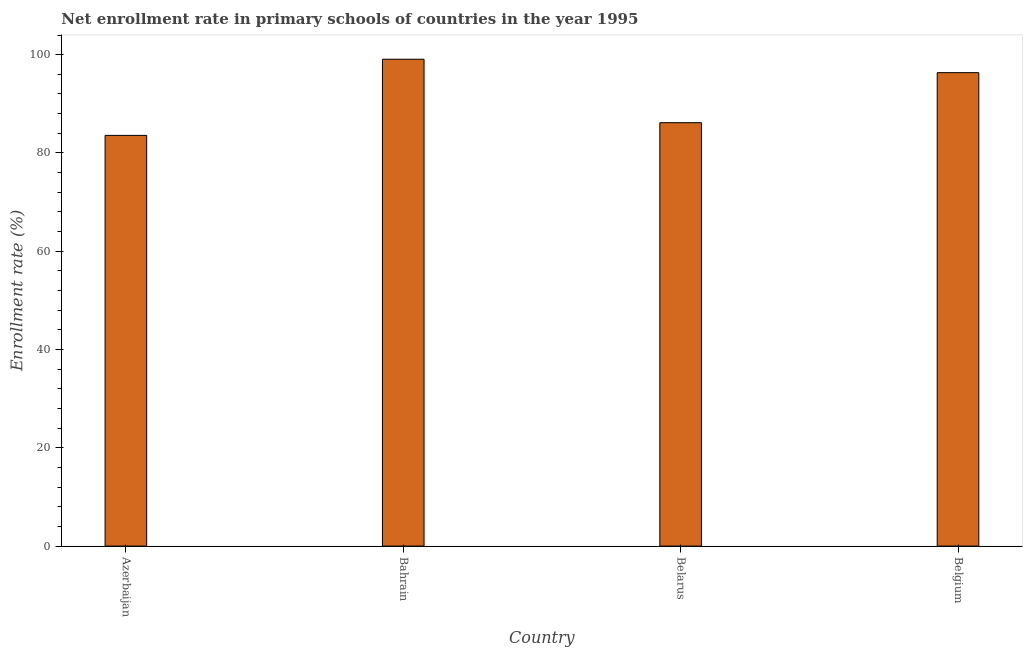What is the title of the graph?
Give a very brief answer. Net enrollment rate in primary schools of countries in the year 1995. What is the label or title of the X-axis?
Ensure brevity in your answer.  Country. What is the label or title of the Y-axis?
Offer a terse response. Enrollment rate (%). What is the net enrollment rate in primary schools in Belgium?
Offer a terse response. 96.34. Across all countries, what is the maximum net enrollment rate in primary schools?
Ensure brevity in your answer.  99.07. Across all countries, what is the minimum net enrollment rate in primary schools?
Ensure brevity in your answer.  83.57. In which country was the net enrollment rate in primary schools maximum?
Offer a terse response. Bahrain. In which country was the net enrollment rate in primary schools minimum?
Keep it short and to the point. Azerbaijan. What is the sum of the net enrollment rate in primary schools?
Offer a very short reply. 365.15. What is the difference between the net enrollment rate in primary schools in Azerbaijan and Belgium?
Offer a terse response. -12.77. What is the average net enrollment rate in primary schools per country?
Offer a very short reply. 91.29. What is the median net enrollment rate in primary schools?
Offer a terse response. 91.25. What is the ratio of the net enrollment rate in primary schools in Azerbaijan to that in Bahrain?
Keep it short and to the point. 0.84. What is the difference between the highest and the second highest net enrollment rate in primary schools?
Your answer should be compact. 2.73. In how many countries, is the net enrollment rate in primary schools greater than the average net enrollment rate in primary schools taken over all countries?
Keep it short and to the point. 2. How many countries are there in the graph?
Give a very brief answer. 4. What is the difference between two consecutive major ticks on the Y-axis?
Your answer should be very brief. 20. Are the values on the major ticks of Y-axis written in scientific E-notation?
Keep it short and to the point. No. What is the Enrollment rate (%) of Azerbaijan?
Ensure brevity in your answer.  83.57. What is the Enrollment rate (%) of Bahrain?
Keep it short and to the point. 99.07. What is the Enrollment rate (%) of Belarus?
Offer a terse response. 86.16. What is the Enrollment rate (%) of Belgium?
Keep it short and to the point. 96.34. What is the difference between the Enrollment rate (%) in Azerbaijan and Bahrain?
Make the answer very short. -15.5. What is the difference between the Enrollment rate (%) in Azerbaijan and Belarus?
Offer a terse response. -2.58. What is the difference between the Enrollment rate (%) in Azerbaijan and Belgium?
Offer a very short reply. -12.77. What is the difference between the Enrollment rate (%) in Bahrain and Belarus?
Your answer should be very brief. 12.92. What is the difference between the Enrollment rate (%) in Bahrain and Belgium?
Provide a succinct answer. 2.73. What is the difference between the Enrollment rate (%) in Belarus and Belgium?
Give a very brief answer. -10.18. What is the ratio of the Enrollment rate (%) in Azerbaijan to that in Bahrain?
Make the answer very short. 0.84. What is the ratio of the Enrollment rate (%) in Azerbaijan to that in Belarus?
Offer a terse response. 0.97. What is the ratio of the Enrollment rate (%) in Azerbaijan to that in Belgium?
Offer a very short reply. 0.87. What is the ratio of the Enrollment rate (%) in Bahrain to that in Belarus?
Give a very brief answer. 1.15. What is the ratio of the Enrollment rate (%) in Bahrain to that in Belgium?
Provide a short and direct response. 1.03. What is the ratio of the Enrollment rate (%) in Belarus to that in Belgium?
Keep it short and to the point. 0.89. 